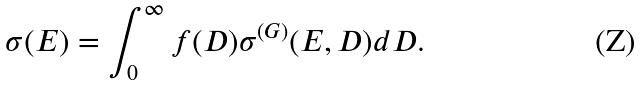Convert formula to latex. <formula><loc_0><loc_0><loc_500><loc_500>\sigma ( E ) = \int _ { 0 } ^ { \infty } f ( D ) \sigma ^ { ( G ) } ( E , D ) d D .</formula> 